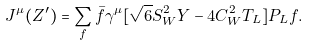Convert formula to latex. <formula><loc_0><loc_0><loc_500><loc_500>J ^ { \mu } ( Z ^ { \prime } ) = \sum _ { f } \bar { f } \gamma ^ { \mu } [ \sqrt { 6 } S ^ { 2 } _ { W } Y - 4 C ^ { 2 } _ { W } T _ { L } ] P _ { L } f .</formula> 